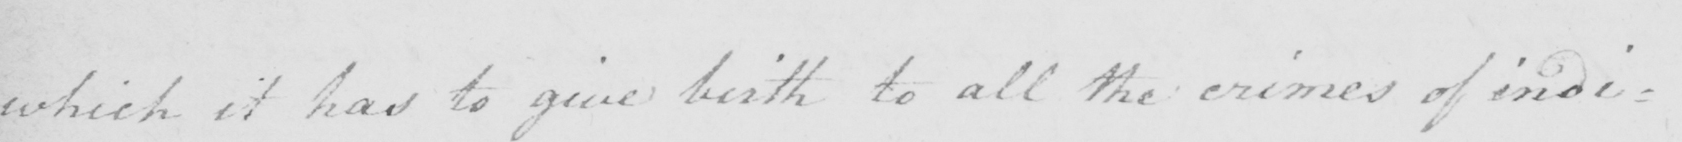What is written in this line of handwriting? which it has to give birth to all the crimes of indi : 